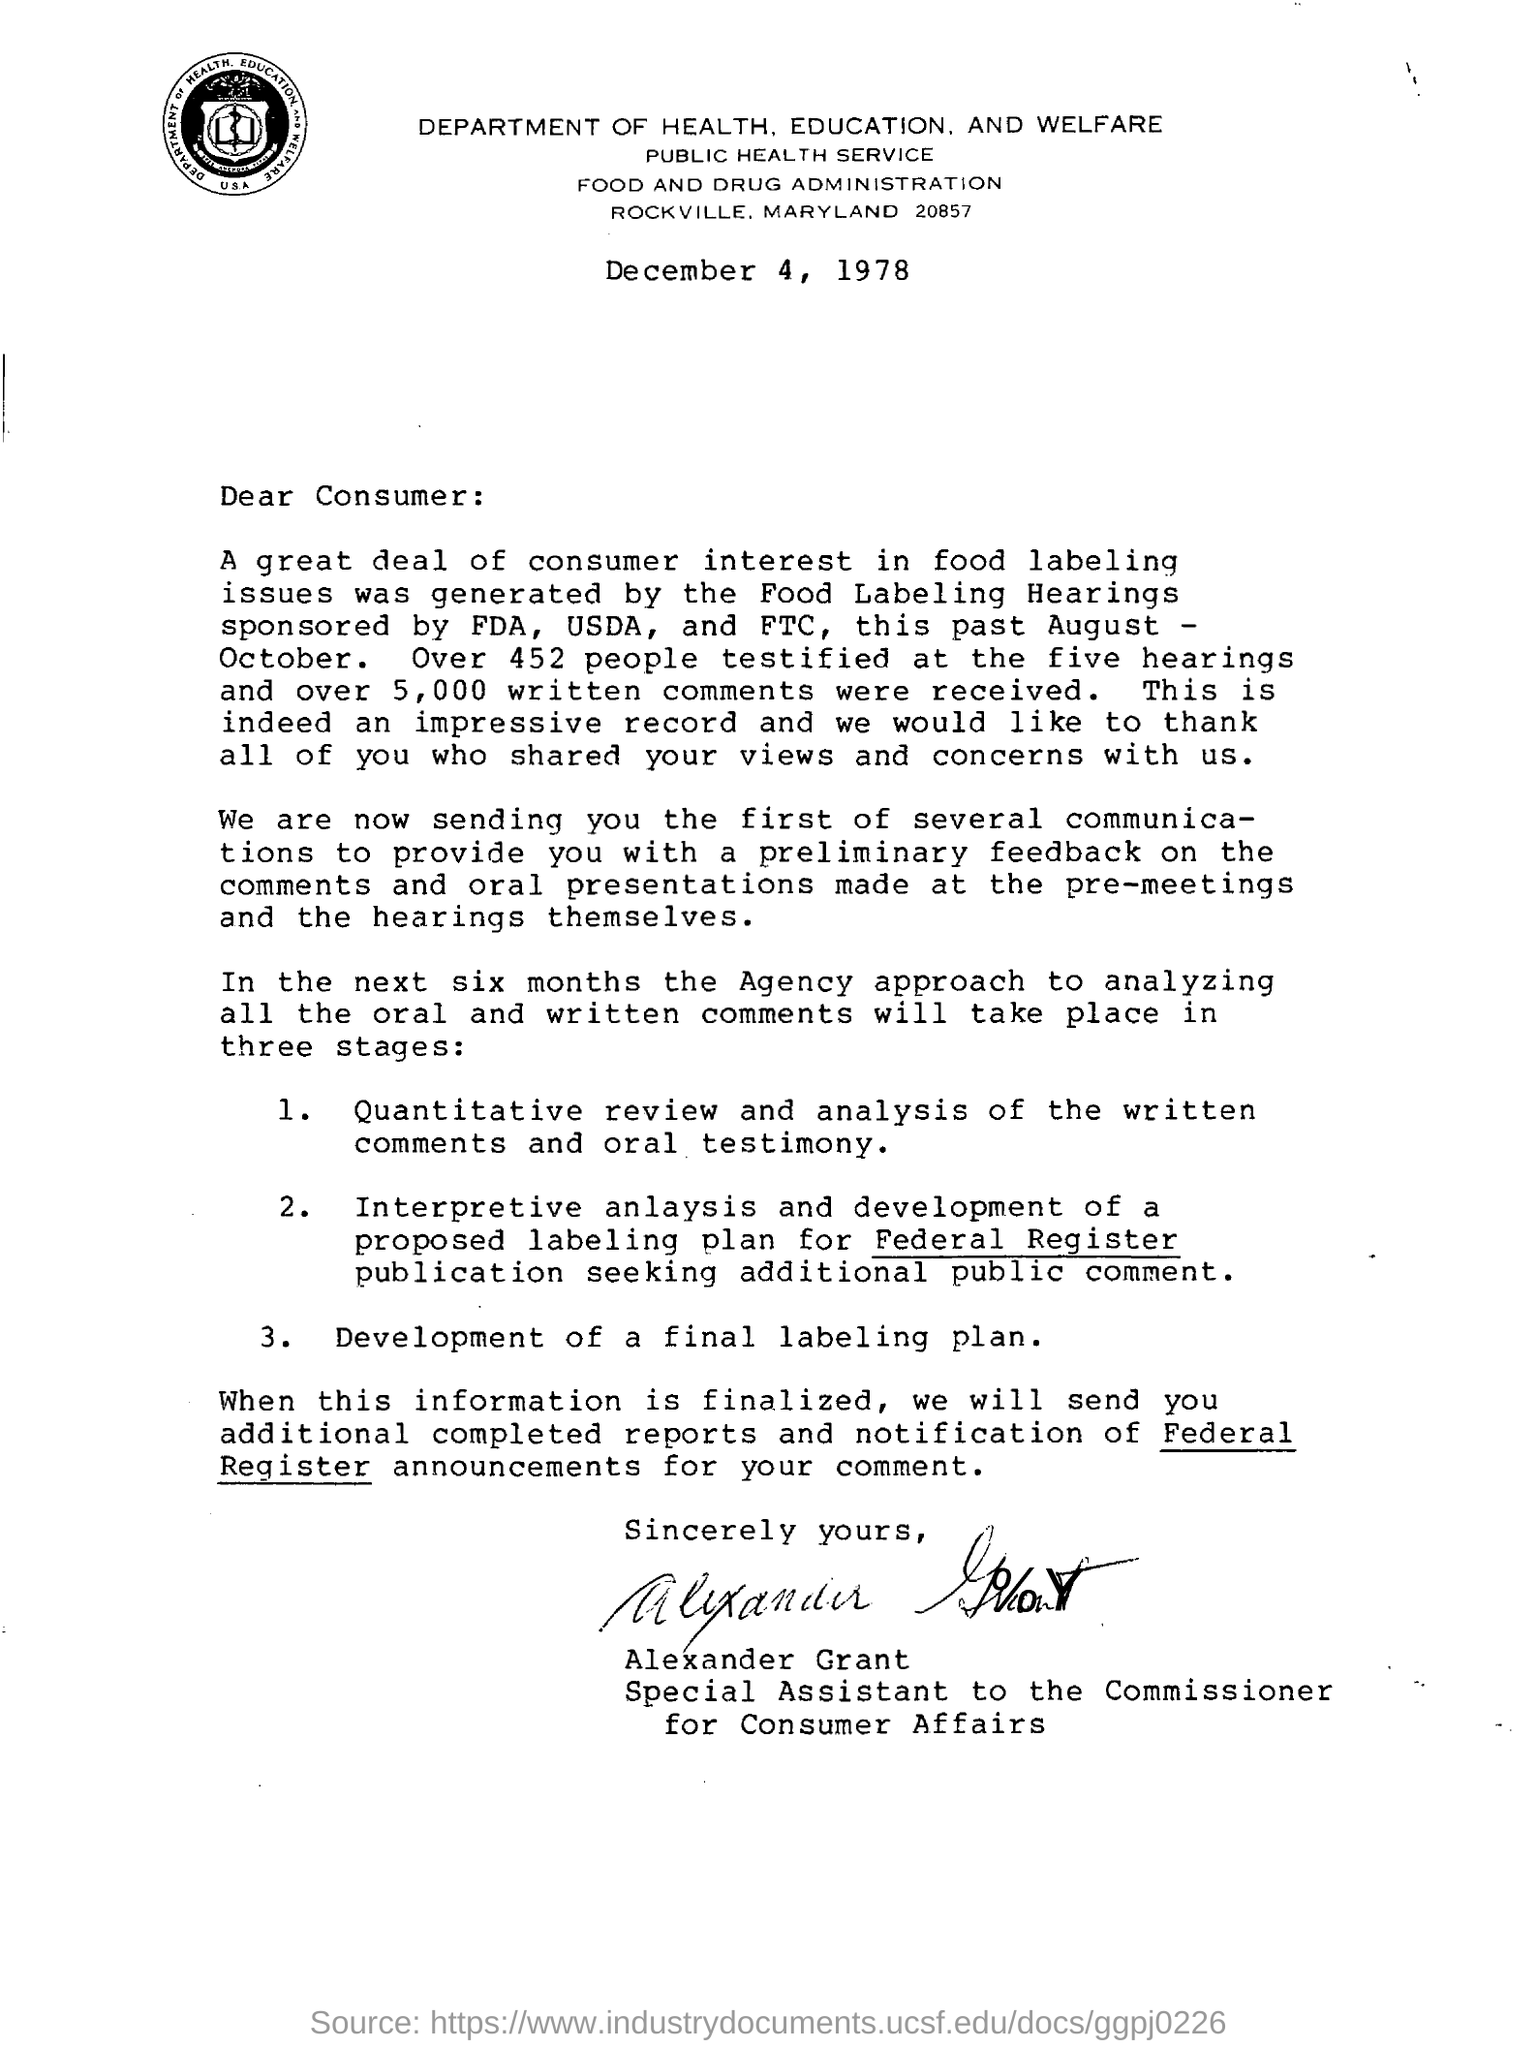List a handful of essential elements in this visual. The document bears the signature of Alexander Grant at the bottom of the page. The Department of Health, Education, and Welfare issued the letter. 